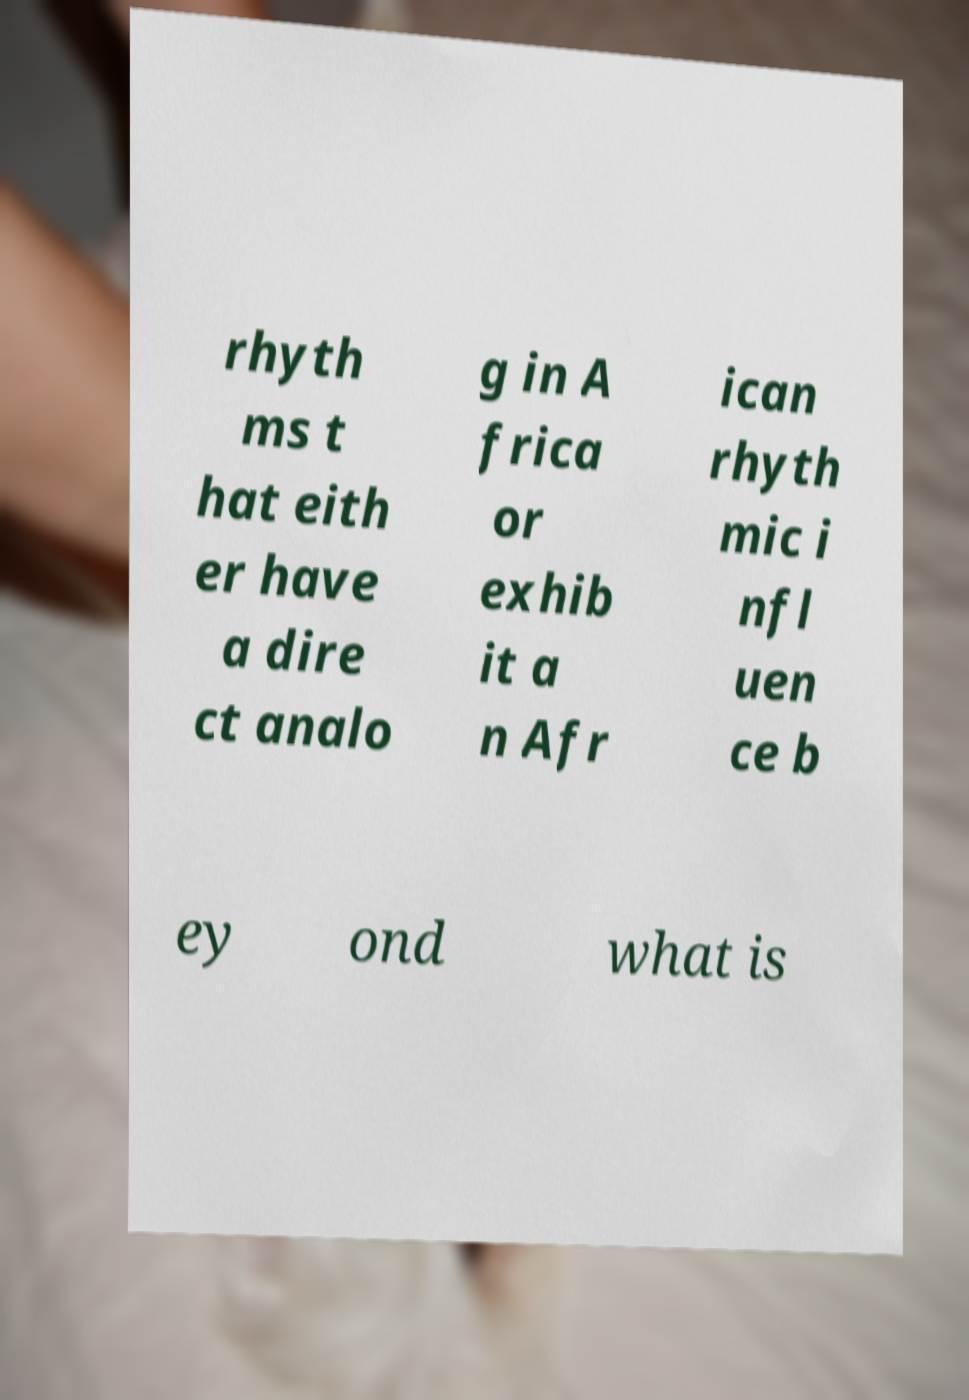Could you extract and type out the text from this image? rhyth ms t hat eith er have a dire ct analo g in A frica or exhib it a n Afr ican rhyth mic i nfl uen ce b ey ond what is 